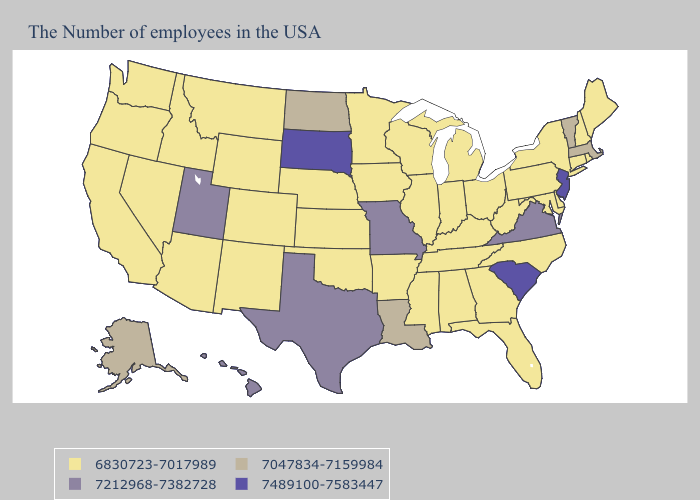Name the states that have a value in the range 7489100-7583447?
Quick response, please. New Jersey, South Carolina, South Dakota. Does Montana have a higher value than Illinois?
Short answer required. No. What is the highest value in the West ?
Concise answer only. 7212968-7382728. What is the highest value in the USA?
Quick response, please. 7489100-7583447. Does New Mexico have the highest value in the West?
Short answer required. No. What is the value of Oklahoma?
Give a very brief answer. 6830723-7017989. Name the states that have a value in the range 6830723-7017989?
Be succinct. Maine, Rhode Island, New Hampshire, Connecticut, New York, Delaware, Maryland, Pennsylvania, North Carolina, West Virginia, Ohio, Florida, Georgia, Michigan, Kentucky, Indiana, Alabama, Tennessee, Wisconsin, Illinois, Mississippi, Arkansas, Minnesota, Iowa, Kansas, Nebraska, Oklahoma, Wyoming, Colorado, New Mexico, Montana, Arizona, Idaho, Nevada, California, Washington, Oregon. Which states have the lowest value in the South?
Concise answer only. Delaware, Maryland, North Carolina, West Virginia, Florida, Georgia, Kentucky, Alabama, Tennessee, Mississippi, Arkansas, Oklahoma. Among the states that border Vermont , does Massachusetts have the lowest value?
Be succinct. No. Does Alabama have the same value as Texas?
Answer briefly. No. What is the highest value in the Northeast ?
Keep it brief. 7489100-7583447. Name the states that have a value in the range 7047834-7159984?
Keep it brief. Massachusetts, Vermont, Louisiana, North Dakota, Alaska. What is the value of Missouri?
Keep it brief. 7212968-7382728. Which states hav the highest value in the South?
Answer briefly. South Carolina. Name the states that have a value in the range 7212968-7382728?
Keep it brief. Virginia, Missouri, Texas, Utah, Hawaii. 